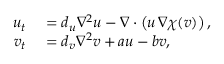<formula> <loc_0><loc_0><loc_500><loc_500>\begin{array} { r l } { u _ { t } } & = d _ { u } \nabla ^ { 2 } u - \nabla \cdot \left ( u \, \nabla \chi ( v ) \right ) , } \\ { v _ { t } } & = d _ { v } \nabla ^ { 2 } v + a u - b v , } \end{array}</formula> 